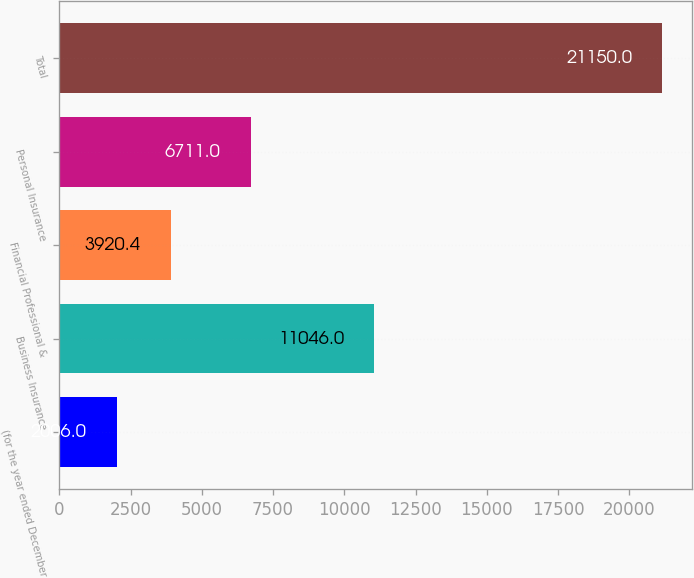<chart> <loc_0><loc_0><loc_500><loc_500><bar_chart><fcel>(for the year ended December<fcel>Business Insurance<fcel>Financial Professional &<fcel>Personal Insurance<fcel>Total<nl><fcel>2006<fcel>11046<fcel>3920.4<fcel>6711<fcel>21150<nl></chart> 